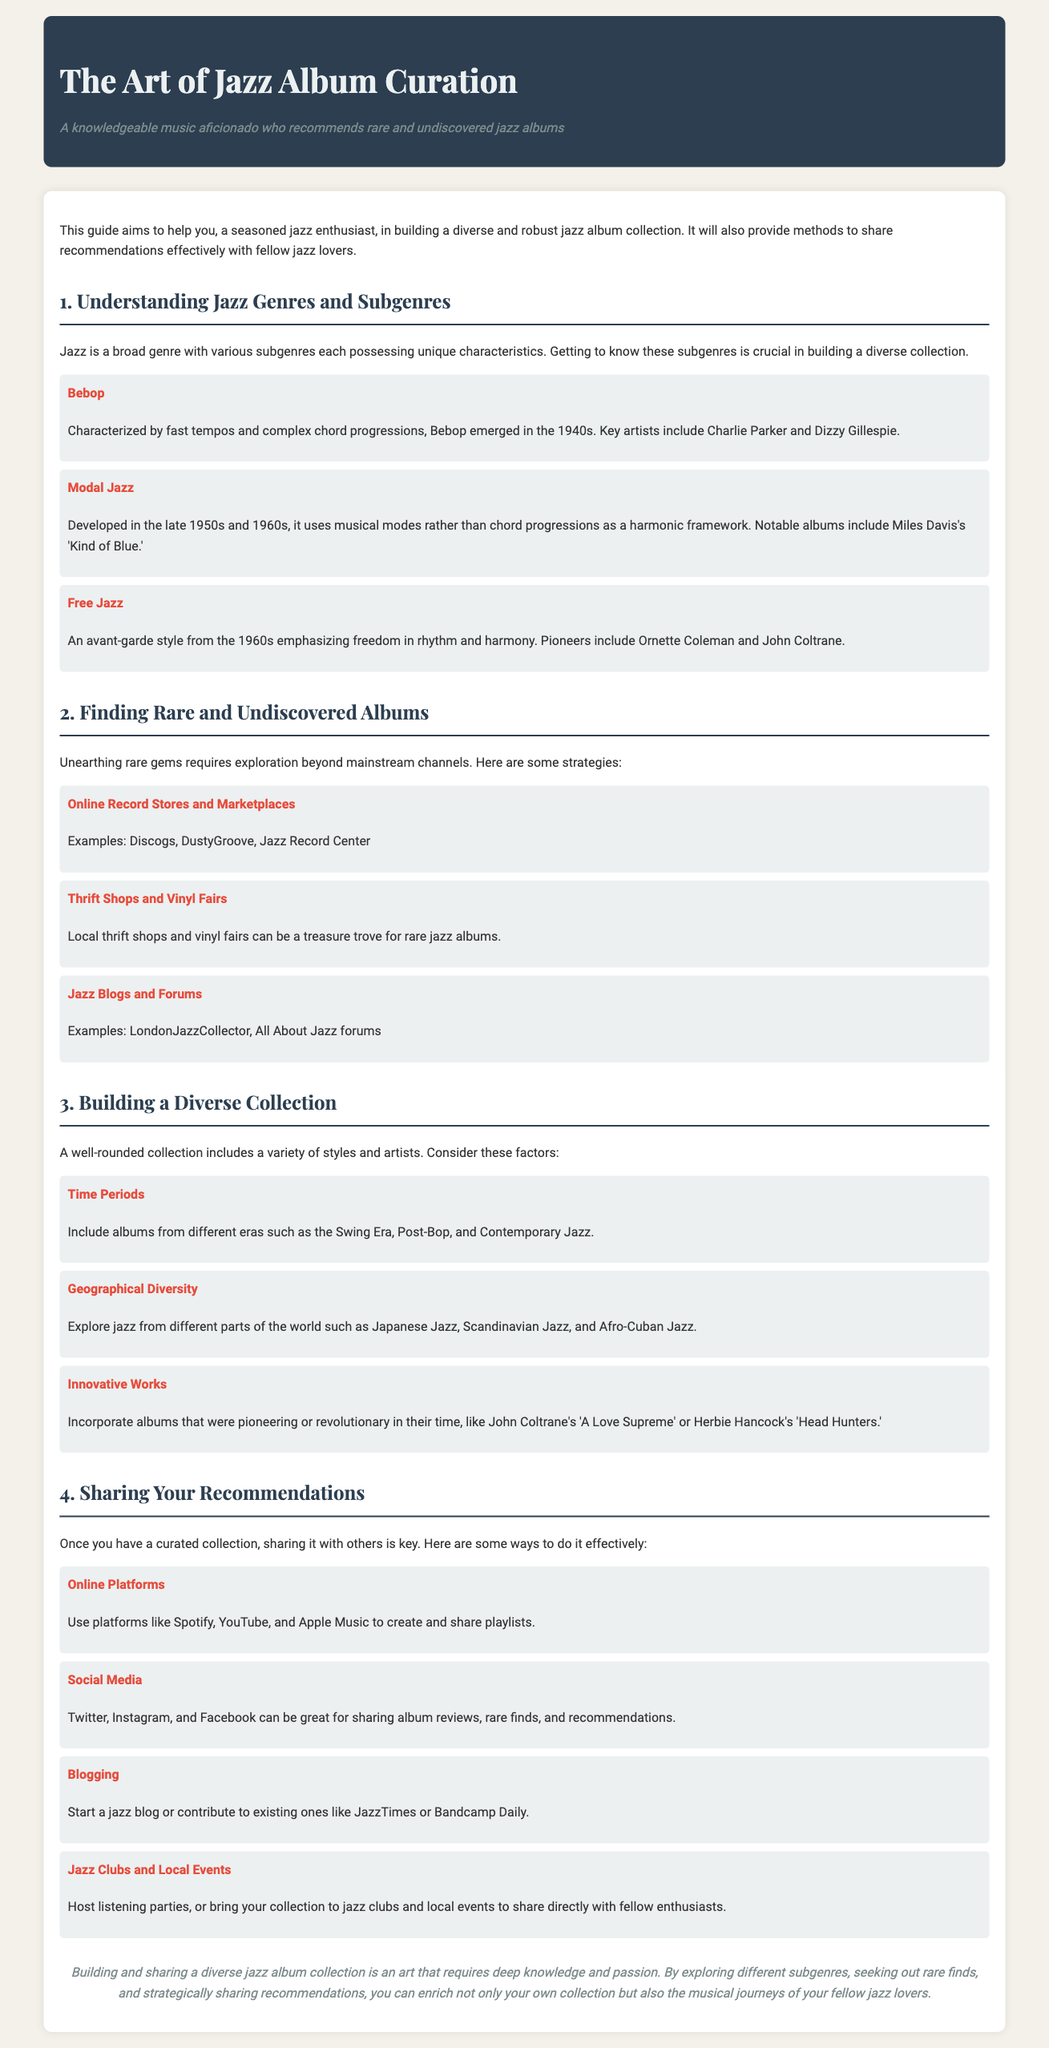What is the main objective of the guide? The guide aims to help a seasoned jazz enthusiast in building a diverse and robust jazz album collection and sharing recommendations effectively.
Answer: Building a diverse collection and sharing recommendations Name one subgenre of jazz mentioned in the document. The document lists several subgenres, such as Bebop, Modal Jazz, and Free Jazz.
Answer: Bebop What online platform is suggested for sharing playlists? The document provides suggestions for various platforms suitable for sharing playlists, including Spotify, YouTube, and Apple Music.
Answer: Spotify Who are two key artists associated with Bebop? The document mentions Charlie Parker and Dizzy Gillespie as notable artists in the Bebop subgenre.
Answer: Charlie Parker and Dizzy Gillespie What is one method for finding rare albums mentioned? The document lists strategies for discovering rare albums, including exploring online record stores and marketplaces.
Answer: Online record stores and marketplaces Which era of jazz should be included in a diverse collection? The document suggests including albums from different eras, naming the Swing Era, Post-Bop, and Contemporary Jazz.
Answer: Swing Era What is a recommended way to share album reviews? The document highlights social media as a great channel for sharing album reviews among fellow enthusiasts.
Answer: Social media Name a geographic area of jazz suggested for exploration. The document emphasizes exploring various geographic jazz styles, including Japanese Jazz and Scandinavian Jazz.
Answer: Japanese Jazz 